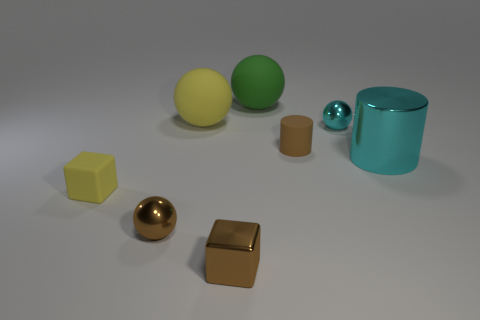What number of other objects are there of the same color as the tiny rubber cylinder?
Give a very brief answer. 2. How big is the metal sphere to the left of the tiny sphere right of the green rubber thing that is on the right side of the rubber cube?
Give a very brief answer. Small. Are there any tiny spheres left of the big yellow matte ball?
Offer a terse response. Yes. Is the size of the cyan cylinder the same as the yellow thing that is behind the brown rubber object?
Your answer should be very brief. Yes. What number of other objects are there of the same material as the brown block?
Provide a succinct answer. 3. There is a large thing that is right of the large yellow matte object and left of the big metal cylinder; what is its shape?
Offer a very short reply. Sphere. There is a cyan metallic thing that is behind the cyan metal cylinder; is it the same size as the rubber ball on the right side of the big yellow rubber ball?
Give a very brief answer. No. There is a small brown object that is the same material as the big green object; what shape is it?
Give a very brief answer. Cylinder. There is a small metal object that is behind the tiny metal sphere on the left side of the big matte thing that is in front of the green sphere; what is its color?
Ensure brevity in your answer.  Cyan. Are there fewer green balls that are left of the large cyan metallic cylinder than small shiny things in front of the tiny yellow rubber block?
Your answer should be compact. Yes. 